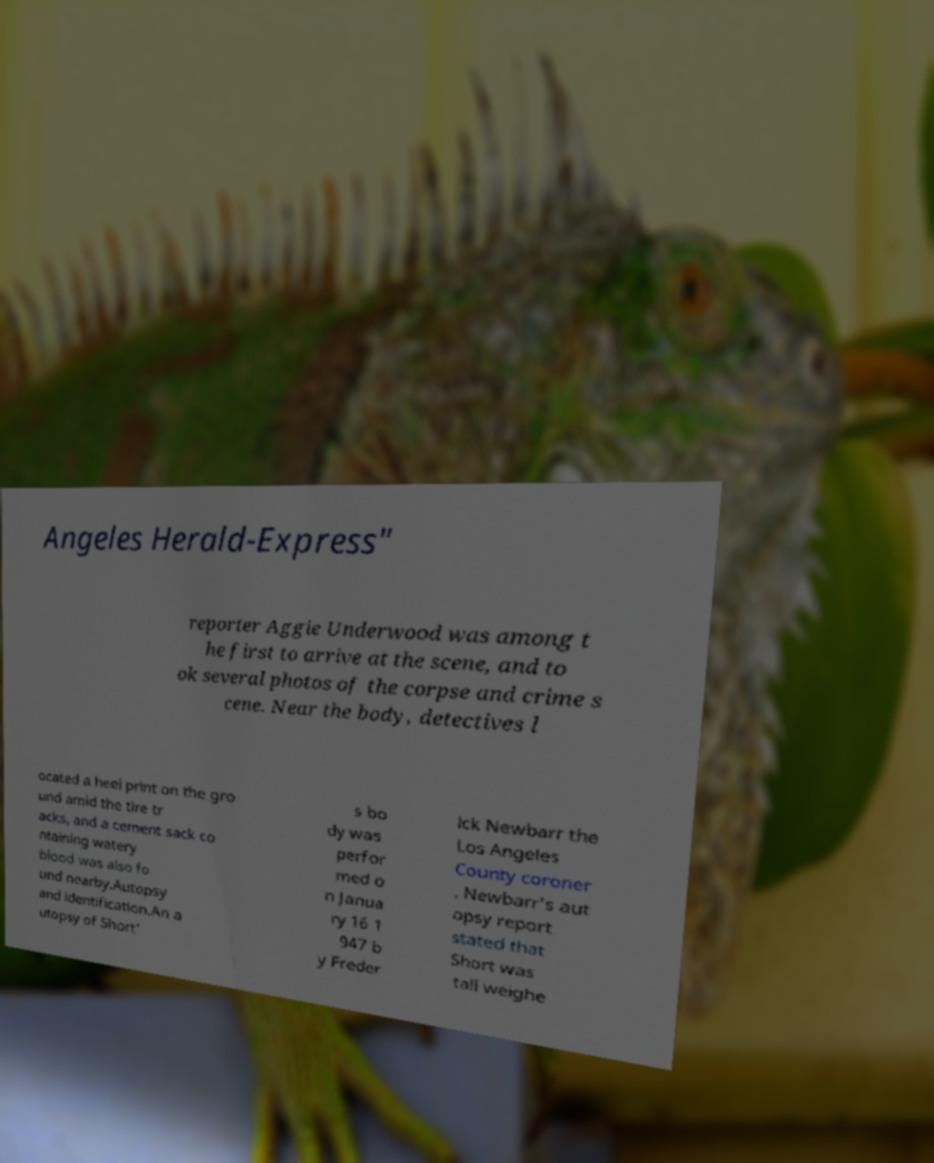Can you accurately transcribe the text from the provided image for me? Angeles Herald-Express" reporter Aggie Underwood was among t he first to arrive at the scene, and to ok several photos of the corpse and crime s cene. Near the body, detectives l ocated a heel print on the gro und amid the tire tr acks, and a cement sack co ntaining watery blood was also fo und nearby.Autopsy and identification.An a utopsy of Short' s bo dy was perfor med o n Janua ry 16 1 947 b y Freder ick Newbarr the Los Angeles County coroner . Newbarr's aut opsy report stated that Short was tall weighe 